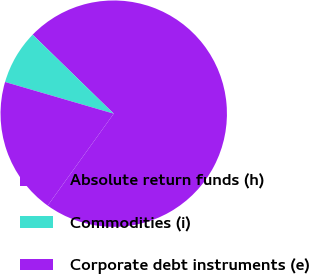Convert chart to OTSL. <chart><loc_0><loc_0><loc_500><loc_500><pie_chart><fcel>Absolute return funds (h)<fcel>Commodities (i)<fcel>Corporate debt instruments (e)<nl><fcel>72.62%<fcel>7.78%<fcel>19.6%<nl></chart> 